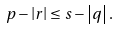<formula> <loc_0><loc_0><loc_500><loc_500>p - \left | r \right | \leq s - \left | q \right | .</formula> 